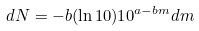Convert formula to latex. <formula><loc_0><loc_0><loc_500><loc_500>d N = - b ( \ln 1 0 ) 1 0 ^ { a - b m } d m</formula> 